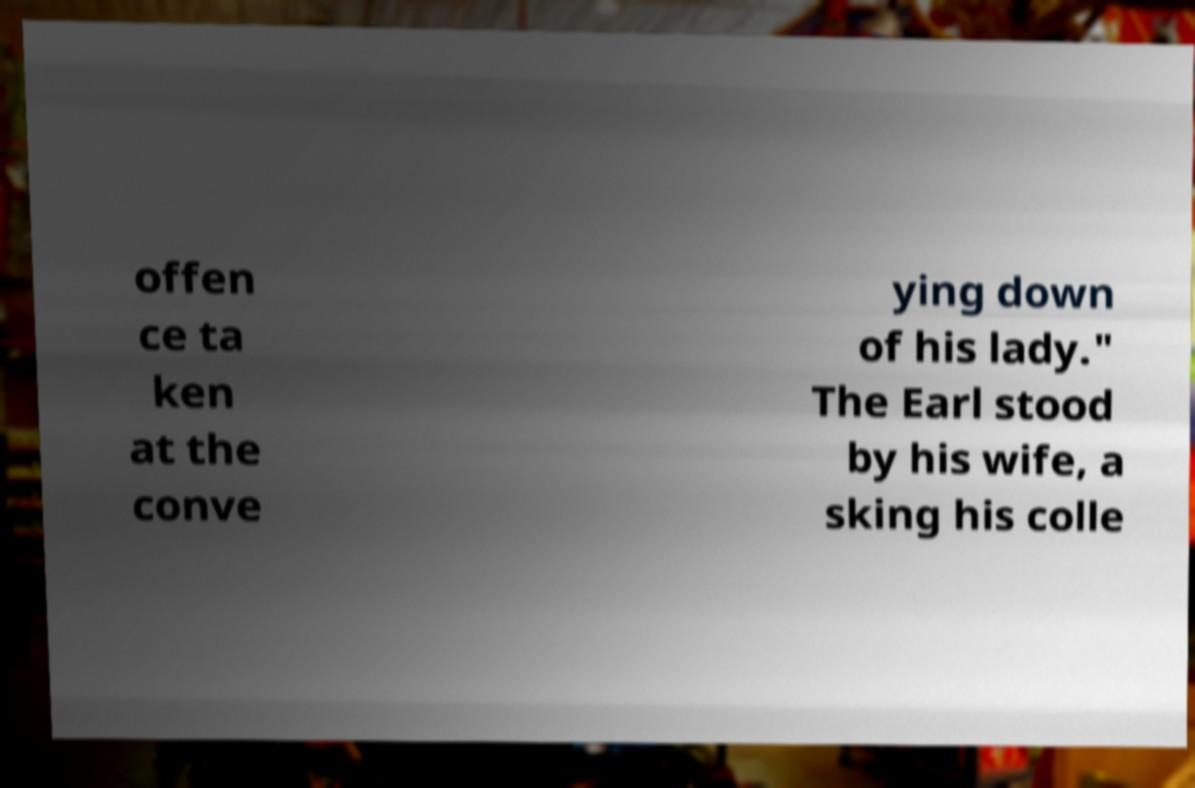Could you assist in decoding the text presented in this image and type it out clearly? offen ce ta ken at the conve ying down of his lady." The Earl stood by his wife, a sking his colle 